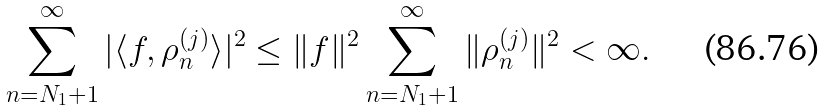<formula> <loc_0><loc_0><loc_500><loc_500>\sum _ { n = N _ { 1 } + 1 } ^ { \infty } | \langle f , \rho _ { n } ^ { ( j ) } \rangle | ^ { 2 } \leq \| f \| ^ { 2 } \sum _ { n = N _ { 1 } + 1 } ^ { \infty } \| \rho _ { n } ^ { ( j ) } \| ^ { 2 } < \infty .</formula> 